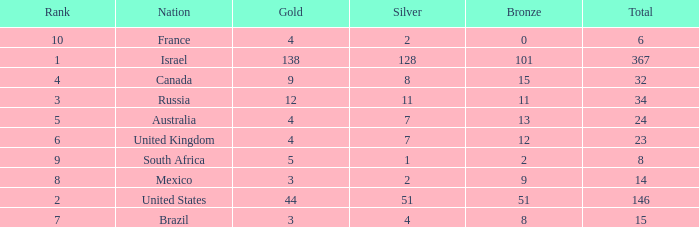What is the maximum number of silvers for a country with fewer than 12 golds and a total less than 8? 2.0. 